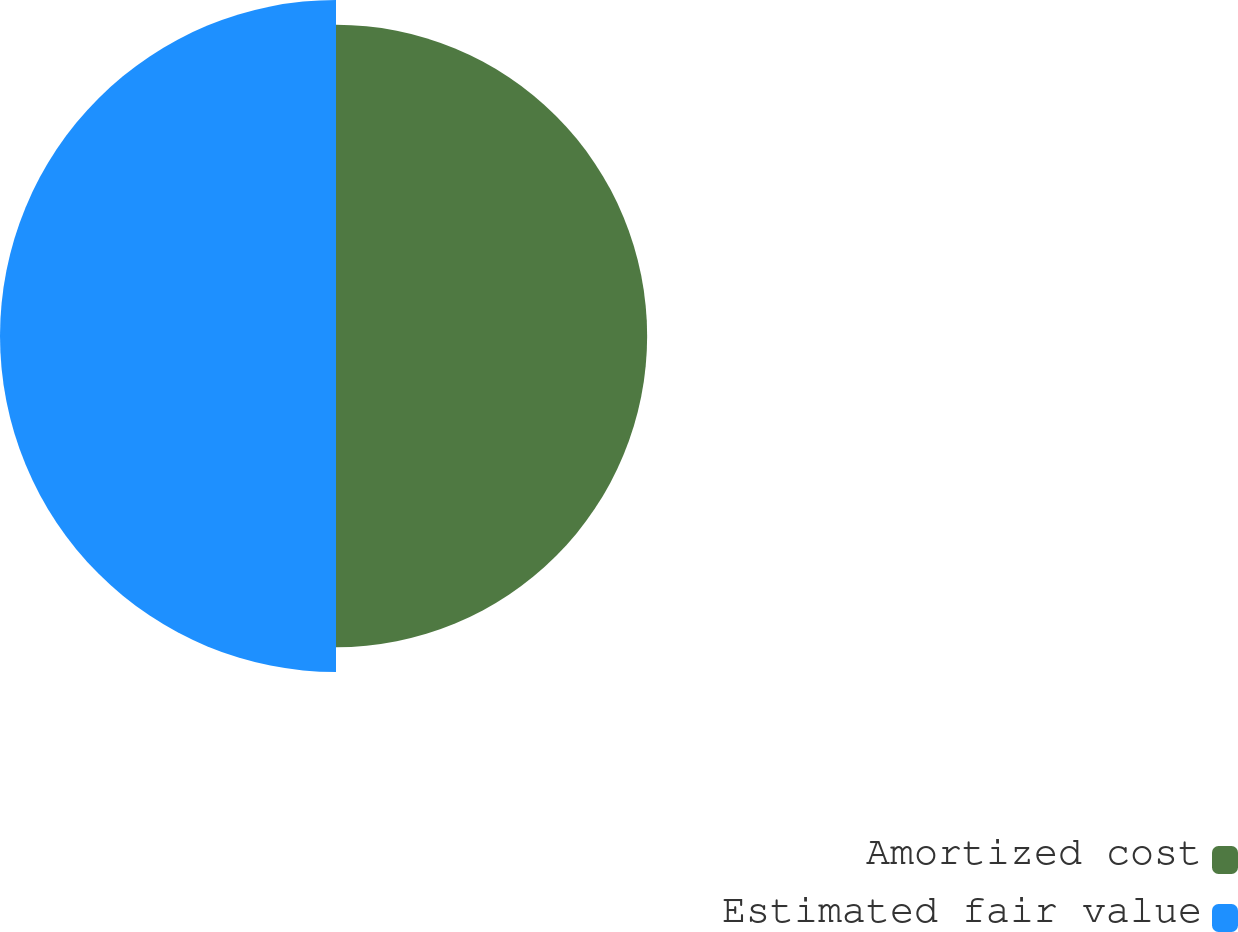Convert chart. <chart><loc_0><loc_0><loc_500><loc_500><pie_chart><fcel>Amortized cost<fcel>Estimated fair value<nl><fcel>48.08%<fcel>51.92%<nl></chart> 